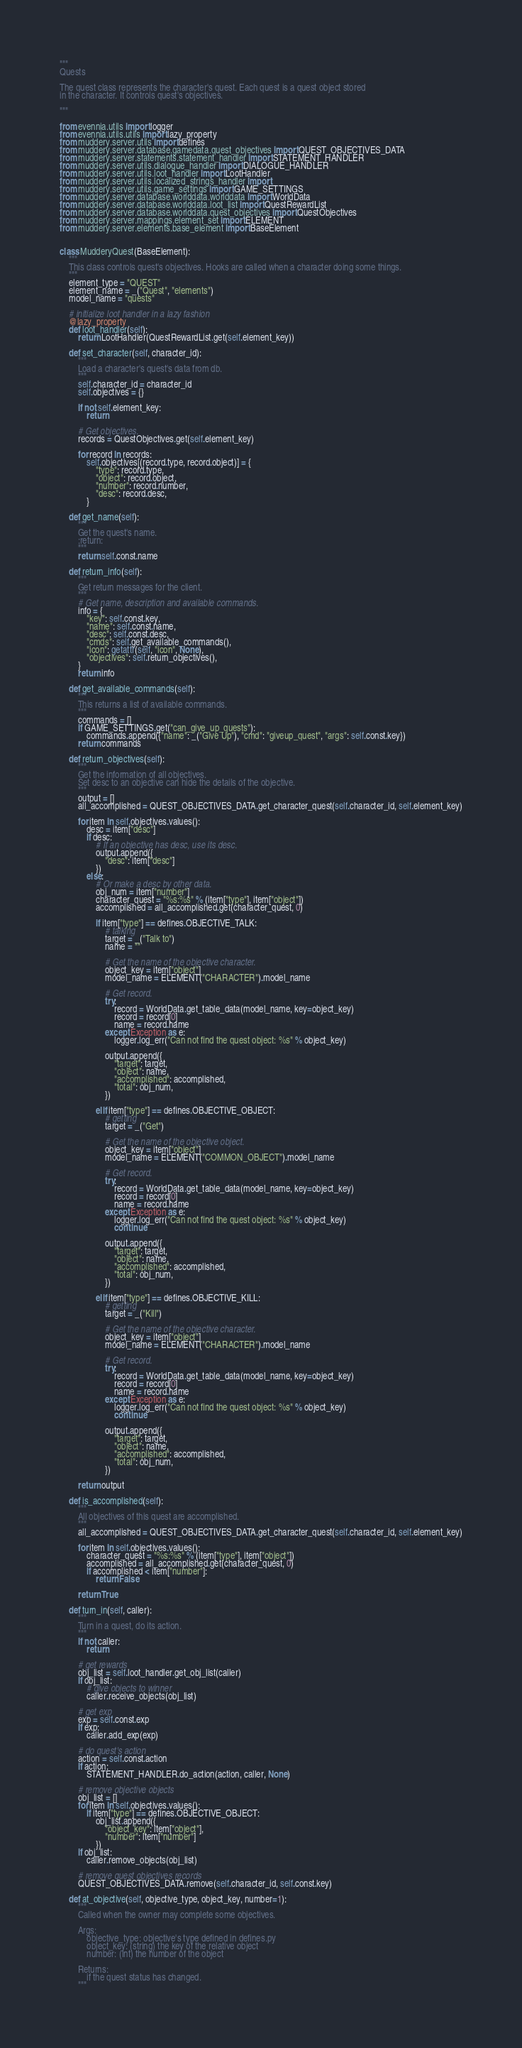<code> <loc_0><loc_0><loc_500><loc_500><_Python_>"""
Quests

The quest class represents the character's quest. Each quest is a quest object stored
in the character. It controls quest's objectives.

"""

from evennia.utils import logger
from evennia.utils.utils import lazy_property
from muddery.server.utils import defines
from muddery.server.database.gamedata.quest_objectives import QUEST_OBJECTIVES_DATA
from muddery.server.statements.statement_handler import STATEMENT_HANDLER
from muddery.server.utils.dialogue_handler import DIALOGUE_HANDLER
from muddery.server.utils.loot_handler import LootHandler
from muddery.server.utils.localized_strings_handler import _
from muddery.server.utils.game_settings import GAME_SETTINGS
from muddery.server.database.worlddata.worlddata import WorldData
from muddery.server.database.worlddata.loot_list import QuestRewardList
from muddery.server.database.worlddata.quest_objectives import QuestObjectives
from muddery.server.mappings.element_set import ELEMENT
from muddery.server.elements.base_element import BaseElement


class MudderyQuest(BaseElement):
    """
    This class controls quest's objectives. Hooks are called when a character doing some things.
    """
    element_type = "QUEST"
    element_name = _("Quest", "elements")
    model_name = "quests"

    # initialize loot handler in a lazy fashion
    @lazy_property
    def loot_handler(self):
        return LootHandler(QuestRewardList.get(self.element_key))

    def set_character(self, character_id):
        """
        Load a character's quest's data from db.
        """
        self.character_id = character_id
        self.objectives = {}

        if not self.element_key:
            return

        # Get objectives.
        records = QuestObjectives.get(self.element_key)

        for record in records:
            self.objectives[(record.type, record.object)] = {
                "type": record.type,
                "object": record.object,
                "number": record.number,
                "desc": record.desc,
            }

    def get_name(self):
        """
        Get the quest's name.
        :return:
        """
        return self.const.name

    def return_info(self):
        """
        Get return messages for the client.
        """
        # Get name, description and available commands.
        info = {
            "key": self.const.key,
            "name": self.const.name,
            "desc": self.const.desc,
            "cmds": self.get_available_commands(),
            "icon": getattr(self, "icon", None),
            "objectives": self.return_objectives(),
        }
        return info

    def get_available_commands(self):
        """
        This returns a list of available commands.
        """
        commands = []
        if GAME_SETTINGS.get("can_give_up_quests"):
            commands.append({"name": _("Give Up"), "cmd": "giveup_quest", "args": self.const.key})
        return commands

    def return_objectives(self):
        """
        Get the information of all objectives.
        Set desc to an objective can hide the details of the objective.
        """
        output = []
        all_accomplished = QUEST_OBJECTIVES_DATA.get_character_quest(self.character_id, self.element_key)

        for item in self.objectives.values():
            desc = item["desc"]
            if desc:
                # If an objective has desc, use its desc.
                output.append({
                    "desc": item["desc"]
                })
            else:
                # Or make a desc by other data.
                obj_num = item["number"]
                character_quest = "%s:%s" % (item["type"], item["object"])
                accomplished = all_accomplished.get(character_quest, 0)
                
                if item["type"] == defines.OBJECTIVE_TALK:
                    # talking
                    target = _("Talk to")
                    name = ""

                    # Get the name of the objective character.
                    object_key = item["object"]
                    model_name = ELEMENT("CHARACTER").model_name

                    # Get record.
                    try:
                        record = WorldData.get_table_data(model_name, key=object_key)
                        record = record[0]
                        name = record.name
                    except Exception as e:
                        logger.log_err("Can not find the quest object: %s" % object_key)
        
                    output.append({
                        "target": target,
                        "object": name,
                        "accomplished": accomplished,
                        "total": obj_num,
                    })

                elif item["type"] == defines.OBJECTIVE_OBJECT:
                    # getting
                    target = _("Get")
                    
                    # Get the name of the objective object.
                    object_key = item["object"]
                    model_name = ELEMENT("COMMON_OBJECT").model_name

                    # Get record.
                    try:
                        record = WorldData.get_table_data(model_name, key=object_key)
                        record = record[0]
                        name = record.name
                    except Exception as e:
                        logger.log_err("Can not find the quest object: %s" % object_key)
                        continue
        
                    output.append({
                        "target": target,
                        "object": name,
                        "accomplished": accomplished,
                        "total": obj_num,
                    })

                elif item["type"] == defines.OBJECTIVE_KILL:
                    # getting
                    target = _("Kill")

                    # Get the name of the objective character.
                    object_key = item["object"]
                    model_name = ELEMENT("CHARACTER").model_name

                    # Get record.
                    try:
                        record = WorldData.get_table_data(model_name, key=object_key)
                        record = record[0]
                        name = record.name
                    except Exception as e:
                        logger.log_err("Can not find the quest object: %s" % object_key)
                        continue

                    output.append({
                        "target": target,
                        "object": name,
                        "accomplished": accomplished,
                        "total": obj_num,
                    })

        return output

    def is_accomplished(self):
        """
        All objectives of this quest are accomplished.
        """
        all_accomplished = QUEST_OBJECTIVES_DATA.get_character_quest(self.character_id, self.element_key)

        for item in self.objectives.values():
            character_quest = "%s:%s" % (item["type"], item["object"])
            accomplished = all_accomplished.get(character_quest, 0)
            if accomplished < item["number"]:
                return False

        return True

    def turn_in(self, caller):
        """
        Turn in a quest, do its action.
        """
        if not caller:
            return

        # get rewards
        obj_list = self.loot_handler.get_obj_list(caller)
        if obj_list:
            # give objects to winner
            caller.receive_objects(obj_list)

        # get exp
        exp = self.const.exp
        if exp:
            caller.add_exp(exp)

        # do quest's action
        action = self.const.action
        if action:
            STATEMENT_HANDLER.do_action(action, caller, None)

        # remove objective objects
        obj_list = []
        for item in self.objectives.values():
            if item["type"] == defines.OBJECTIVE_OBJECT:
                obj_list.append({
                    "object_key": item["object"],
                    "number": item["number"]
                })
        if obj_list:
            caller.remove_objects(obj_list)

        # remove quest objectives records
        QUEST_OBJECTIVES_DATA.remove(self.character_id, self.const.key)

    def at_objective(self, objective_type, object_key, number=1):
        """
        Called when the owner may complete some objectives.
        
        Args:
            objective_type: objective's type defined in defines.py
            object_key: (string) the key of the relative object
            number: (int) the number of the object
        
        Returns:
            if the quest status has changed.
        """</code> 